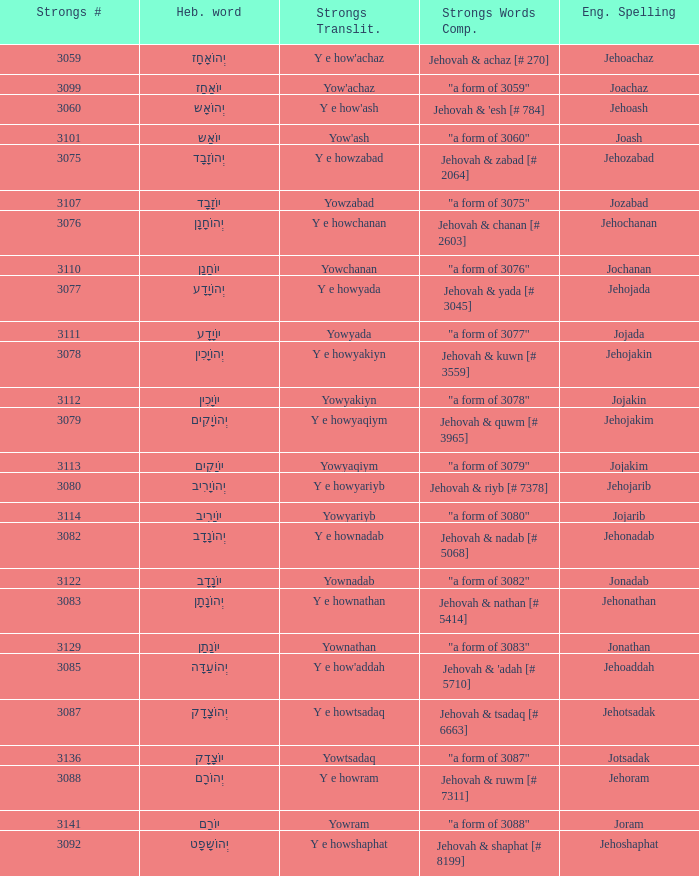How many strongs transliteration of the english spelling of the work jehojakin? 1.0. 